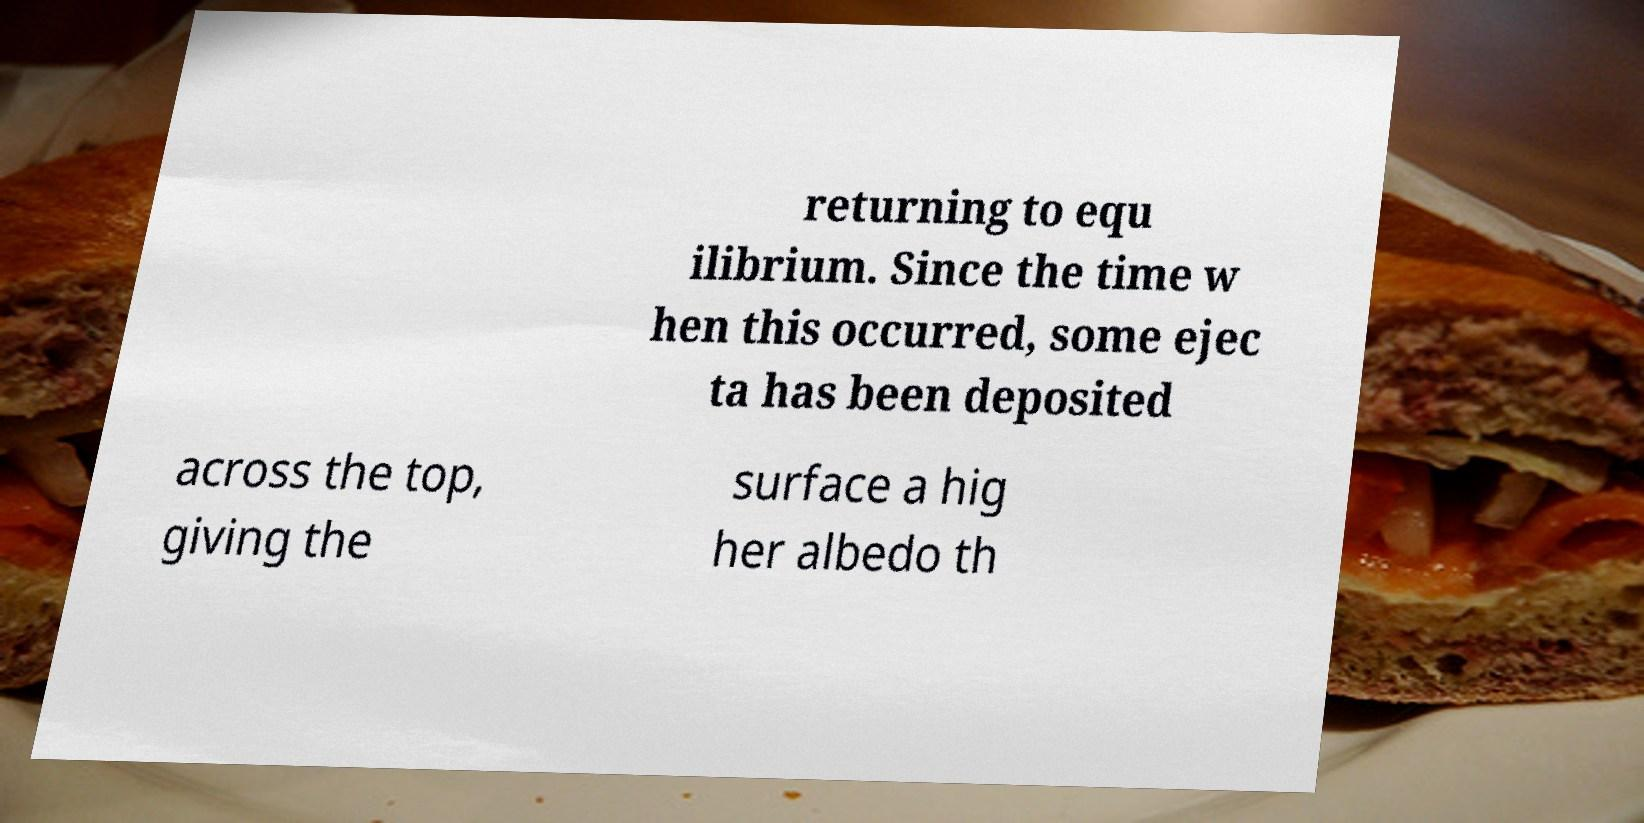Could you extract and type out the text from this image? returning to equ ilibrium. Since the time w hen this occurred, some ejec ta has been deposited across the top, giving the surface a hig her albedo th 